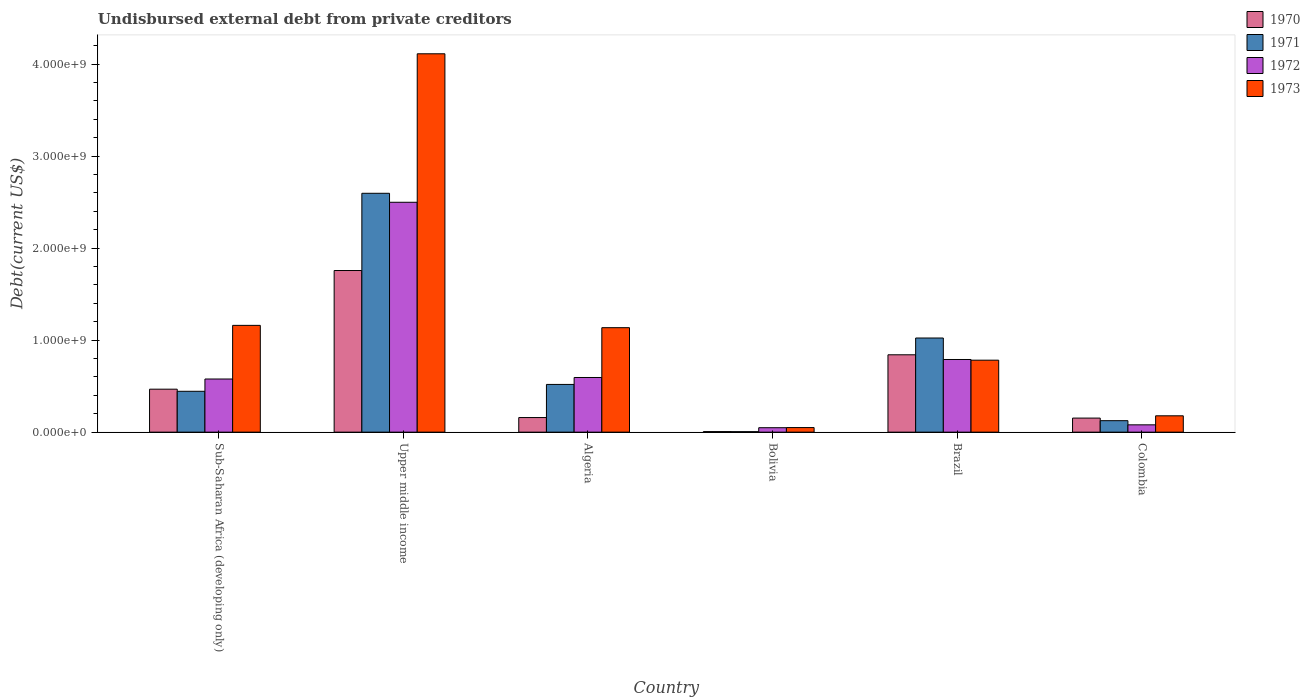How many groups of bars are there?
Offer a very short reply. 6. Are the number of bars per tick equal to the number of legend labels?
Keep it short and to the point. Yes. How many bars are there on the 1st tick from the left?
Give a very brief answer. 4. What is the label of the 3rd group of bars from the left?
Your response must be concise. Algeria. What is the total debt in 1972 in Algeria?
Your answer should be very brief. 5.94e+08. Across all countries, what is the maximum total debt in 1970?
Give a very brief answer. 1.76e+09. Across all countries, what is the minimum total debt in 1972?
Provide a short and direct response. 4.82e+07. In which country was the total debt in 1971 maximum?
Your answer should be compact. Upper middle income. What is the total total debt in 1970 in the graph?
Provide a succinct answer. 3.38e+09. What is the difference between the total debt in 1972 in Algeria and that in Brazil?
Your answer should be very brief. -1.95e+08. What is the difference between the total debt in 1970 in Colombia and the total debt in 1971 in Bolivia?
Offer a terse response. 1.48e+08. What is the average total debt in 1973 per country?
Provide a short and direct response. 1.24e+09. What is the difference between the total debt of/in 1973 and total debt of/in 1970 in Algeria?
Your response must be concise. 9.77e+08. What is the ratio of the total debt in 1972 in Bolivia to that in Upper middle income?
Offer a very short reply. 0.02. Is the total debt in 1970 in Sub-Saharan Africa (developing only) less than that in Upper middle income?
Your answer should be very brief. Yes. What is the difference between the highest and the second highest total debt in 1973?
Your answer should be very brief. 2.95e+09. What is the difference between the highest and the lowest total debt in 1970?
Offer a terse response. 1.75e+09. Is the sum of the total debt in 1973 in Bolivia and Upper middle income greater than the maximum total debt in 1970 across all countries?
Make the answer very short. Yes. Is it the case that in every country, the sum of the total debt in 1970 and total debt in 1972 is greater than the sum of total debt in 1973 and total debt in 1971?
Provide a succinct answer. No. What does the 3rd bar from the left in Bolivia represents?
Your answer should be very brief. 1972. How many bars are there?
Offer a very short reply. 24. How many countries are there in the graph?
Make the answer very short. 6. What is the difference between two consecutive major ticks on the Y-axis?
Provide a succinct answer. 1.00e+09. Does the graph contain grids?
Your answer should be very brief. No. Where does the legend appear in the graph?
Provide a short and direct response. Top right. What is the title of the graph?
Keep it short and to the point. Undisbursed external debt from private creditors. What is the label or title of the Y-axis?
Provide a succinct answer. Debt(current US$). What is the Debt(current US$) of 1970 in Sub-Saharan Africa (developing only)?
Your answer should be compact. 4.67e+08. What is the Debt(current US$) of 1971 in Sub-Saharan Africa (developing only)?
Give a very brief answer. 4.44e+08. What is the Debt(current US$) in 1972 in Sub-Saharan Africa (developing only)?
Provide a short and direct response. 5.77e+08. What is the Debt(current US$) in 1973 in Sub-Saharan Africa (developing only)?
Your answer should be compact. 1.16e+09. What is the Debt(current US$) of 1970 in Upper middle income?
Keep it short and to the point. 1.76e+09. What is the Debt(current US$) in 1971 in Upper middle income?
Give a very brief answer. 2.60e+09. What is the Debt(current US$) in 1972 in Upper middle income?
Ensure brevity in your answer.  2.50e+09. What is the Debt(current US$) of 1973 in Upper middle income?
Your answer should be very brief. 4.11e+09. What is the Debt(current US$) in 1970 in Algeria?
Keep it short and to the point. 1.59e+08. What is the Debt(current US$) of 1971 in Algeria?
Your answer should be very brief. 5.18e+08. What is the Debt(current US$) of 1972 in Algeria?
Make the answer very short. 5.94e+08. What is the Debt(current US$) of 1973 in Algeria?
Keep it short and to the point. 1.14e+09. What is the Debt(current US$) of 1970 in Bolivia?
Give a very brief answer. 6.05e+06. What is the Debt(current US$) in 1971 in Bolivia?
Keep it short and to the point. 5.25e+06. What is the Debt(current US$) of 1972 in Bolivia?
Provide a succinct answer. 4.82e+07. What is the Debt(current US$) in 1973 in Bolivia?
Your answer should be compact. 4.98e+07. What is the Debt(current US$) of 1970 in Brazil?
Provide a succinct answer. 8.41e+08. What is the Debt(current US$) in 1971 in Brazil?
Your response must be concise. 1.02e+09. What is the Debt(current US$) of 1972 in Brazil?
Ensure brevity in your answer.  7.89e+08. What is the Debt(current US$) in 1973 in Brazil?
Make the answer very short. 7.82e+08. What is the Debt(current US$) in 1970 in Colombia?
Your answer should be very brief. 1.53e+08. What is the Debt(current US$) in 1971 in Colombia?
Offer a very short reply. 1.25e+08. What is the Debt(current US$) of 1972 in Colombia?
Give a very brief answer. 7.95e+07. What is the Debt(current US$) of 1973 in Colombia?
Your response must be concise. 1.78e+08. Across all countries, what is the maximum Debt(current US$) of 1970?
Offer a very short reply. 1.76e+09. Across all countries, what is the maximum Debt(current US$) of 1971?
Make the answer very short. 2.60e+09. Across all countries, what is the maximum Debt(current US$) of 1972?
Your answer should be very brief. 2.50e+09. Across all countries, what is the maximum Debt(current US$) in 1973?
Offer a very short reply. 4.11e+09. Across all countries, what is the minimum Debt(current US$) in 1970?
Give a very brief answer. 6.05e+06. Across all countries, what is the minimum Debt(current US$) of 1971?
Your answer should be very brief. 5.25e+06. Across all countries, what is the minimum Debt(current US$) of 1972?
Your response must be concise. 4.82e+07. Across all countries, what is the minimum Debt(current US$) in 1973?
Ensure brevity in your answer.  4.98e+07. What is the total Debt(current US$) of 1970 in the graph?
Give a very brief answer. 3.38e+09. What is the total Debt(current US$) in 1971 in the graph?
Your answer should be very brief. 4.71e+09. What is the total Debt(current US$) in 1972 in the graph?
Provide a succinct answer. 4.59e+09. What is the total Debt(current US$) of 1973 in the graph?
Your answer should be compact. 7.42e+09. What is the difference between the Debt(current US$) in 1970 in Sub-Saharan Africa (developing only) and that in Upper middle income?
Ensure brevity in your answer.  -1.29e+09. What is the difference between the Debt(current US$) in 1971 in Sub-Saharan Africa (developing only) and that in Upper middle income?
Provide a short and direct response. -2.15e+09. What is the difference between the Debt(current US$) in 1972 in Sub-Saharan Africa (developing only) and that in Upper middle income?
Provide a succinct answer. -1.92e+09. What is the difference between the Debt(current US$) in 1973 in Sub-Saharan Africa (developing only) and that in Upper middle income?
Offer a terse response. -2.95e+09. What is the difference between the Debt(current US$) of 1970 in Sub-Saharan Africa (developing only) and that in Algeria?
Offer a terse response. 3.08e+08. What is the difference between the Debt(current US$) in 1971 in Sub-Saharan Africa (developing only) and that in Algeria?
Give a very brief answer. -7.44e+07. What is the difference between the Debt(current US$) in 1972 in Sub-Saharan Africa (developing only) and that in Algeria?
Ensure brevity in your answer.  -1.64e+07. What is the difference between the Debt(current US$) in 1973 in Sub-Saharan Africa (developing only) and that in Algeria?
Offer a terse response. 2.52e+07. What is the difference between the Debt(current US$) of 1970 in Sub-Saharan Africa (developing only) and that in Bolivia?
Your response must be concise. 4.61e+08. What is the difference between the Debt(current US$) in 1971 in Sub-Saharan Africa (developing only) and that in Bolivia?
Provide a short and direct response. 4.39e+08. What is the difference between the Debt(current US$) in 1972 in Sub-Saharan Africa (developing only) and that in Bolivia?
Keep it short and to the point. 5.29e+08. What is the difference between the Debt(current US$) of 1973 in Sub-Saharan Africa (developing only) and that in Bolivia?
Give a very brief answer. 1.11e+09. What is the difference between the Debt(current US$) of 1970 in Sub-Saharan Africa (developing only) and that in Brazil?
Give a very brief answer. -3.74e+08. What is the difference between the Debt(current US$) in 1971 in Sub-Saharan Africa (developing only) and that in Brazil?
Make the answer very short. -5.79e+08. What is the difference between the Debt(current US$) of 1972 in Sub-Saharan Africa (developing only) and that in Brazil?
Your response must be concise. -2.12e+08. What is the difference between the Debt(current US$) of 1973 in Sub-Saharan Africa (developing only) and that in Brazil?
Give a very brief answer. 3.78e+08. What is the difference between the Debt(current US$) in 1970 in Sub-Saharan Africa (developing only) and that in Colombia?
Make the answer very short. 3.14e+08. What is the difference between the Debt(current US$) of 1971 in Sub-Saharan Africa (developing only) and that in Colombia?
Provide a succinct answer. 3.19e+08. What is the difference between the Debt(current US$) of 1972 in Sub-Saharan Africa (developing only) and that in Colombia?
Provide a succinct answer. 4.98e+08. What is the difference between the Debt(current US$) of 1973 in Sub-Saharan Africa (developing only) and that in Colombia?
Offer a terse response. 9.83e+08. What is the difference between the Debt(current US$) of 1970 in Upper middle income and that in Algeria?
Ensure brevity in your answer.  1.60e+09. What is the difference between the Debt(current US$) in 1971 in Upper middle income and that in Algeria?
Your answer should be compact. 2.08e+09. What is the difference between the Debt(current US$) in 1972 in Upper middle income and that in Algeria?
Offer a very short reply. 1.90e+09. What is the difference between the Debt(current US$) of 1973 in Upper middle income and that in Algeria?
Provide a succinct answer. 2.98e+09. What is the difference between the Debt(current US$) in 1970 in Upper middle income and that in Bolivia?
Keep it short and to the point. 1.75e+09. What is the difference between the Debt(current US$) in 1971 in Upper middle income and that in Bolivia?
Provide a succinct answer. 2.59e+09. What is the difference between the Debt(current US$) in 1972 in Upper middle income and that in Bolivia?
Your answer should be compact. 2.45e+09. What is the difference between the Debt(current US$) of 1973 in Upper middle income and that in Bolivia?
Give a very brief answer. 4.06e+09. What is the difference between the Debt(current US$) in 1970 in Upper middle income and that in Brazil?
Make the answer very short. 9.16e+08. What is the difference between the Debt(current US$) of 1971 in Upper middle income and that in Brazil?
Your answer should be compact. 1.57e+09. What is the difference between the Debt(current US$) of 1972 in Upper middle income and that in Brazil?
Give a very brief answer. 1.71e+09. What is the difference between the Debt(current US$) in 1973 in Upper middle income and that in Brazil?
Provide a succinct answer. 3.33e+09. What is the difference between the Debt(current US$) of 1970 in Upper middle income and that in Colombia?
Your response must be concise. 1.60e+09. What is the difference between the Debt(current US$) of 1971 in Upper middle income and that in Colombia?
Your answer should be very brief. 2.47e+09. What is the difference between the Debt(current US$) of 1972 in Upper middle income and that in Colombia?
Ensure brevity in your answer.  2.42e+09. What is the difference between the Debt(current US$) of 1973 in Upper middle income and that in Colombia?
Keep it short and to the point. 3.93e+09. What is the difference between the Debt(current US$) of 1970 in Algeria and that in Bolivia?
Give a very brief answer. 1.53e+08. What is the difference between the Debt(current US$) of 1971 in Algeria and that in Bolivia?
Keep it short and to the point. 5.13e+08. What is the difference between the Debt(current US$) of 1972 in Algeria and that in Bolivia?
Provide a short and direct response. 5.46e+08. What is the difference between the Debt(current US$) in 1973 in Algeria and that in Bolivia?
Your response must be concise. 1.09e+09. What is the difference between the Debt(current US$) in 1970 in Algeria and that in Brazil?
Offer a very short reply. -6.82e+08. What is the difference between the Debt(current US$) in 1971 in Algeria and that in Brazil?
Keep it short and to the point. -5.05e+08. What is the difference between the Debt(current US$) of 1972 in Algeria and that in Brazil?
Keep it short and to the point. -1.95e+08. What is the difference between the Debt(current US$) in 1973 in Algeria and that in Brazil?
Offer a very short reply. 3.53e+08. What is the difference between the Debt(current US$) of 1970 in Algeria and that in Colombia?
Keep it short and to the point. 5.77e+06. What is the difference between the Debt(current US$) of 1971 in Algeria and that in Colombia?
Your answer should be very brief. 3.94e+08. What is the difference between the Debt(current US$) in 1972 in Algeria and that in Colombia?
Offer a terse response. 5.14e+08. What is the difference between the Debt(current US$) of 1973 in Algeria and that in Colombia?
Offer a terse response. 9.58e+08. What is the difference between the Debt(current US$) of 1970 in Bolivia and that in Brazil?
Offer a very short reply. -8.35e+08. What is the difference between the Debt(current US$) of 1971 in Bolivia and that in Brazil?
Provide a short and direct response. -1.02e+09. What is the difference between the Debt(current US$) in 1972 in Bolivia and that in Brazil?
Offer a very short reply. -7.41e+08. What is the difference between the Debt(current US$) of 1973 in Bolivia and that in Brazil?
Offer a very short reply. -7.32e+08. What is the difference between the Debt(current US$) in 1970 in Bolivia and that in Colombia?
Your response must be concise. -1.47e+08. What is the difference between the Debt(current US$) of 1971 in Bolivia and that in Colombia?
Your response must be concise. -1.19e+08. What is the difference between the Debt(current US$) of 1972 in Bolivia and that in Colombia?
Keep it short and to the point. -3.13e+07. What is the difference between the Debt(current US$) in 1973 in Bolivia and that in Colombia?
Offer a terse response. -1.28e+08. What is the difference between the Debt(current US$) in 1970 in Brazil and that in Colombia?
Make the answer very short. 6.88e+08. What is the difference between the Debt(current US$) in 1971 in Brazil and that in Colombia?
Make the answer very short. 8.98e+08. What is the difference between the Debt(current US$) of 1972 in Brazil and that in Colombia?
Give a very brief answer. 7.10e+08. What is the difference between the Debt(current US$) in 1973 in Brazil and that in Colombia?
Keep it short and to the point. 6.04e+08. What is the difference between the Debt(current US$) of 1970 in Sub-Saharan Africa (developing only) and the Debt(current US$) of 1971 in Upper middle income?
Offer a very short reply. -2.13e+09. What is the difference between the Debt(current US$) in 1970 in Sub-Saharan Africa (developing only) and the Debt(current US$) in 1972 in Upper middle income?
Offer a terse response. -2.03e+09. What is the difference between the Debt(current US$) of 1970 in Sub-Saharan Africa (developing only) and the Debt(current US$) of 1973 in Upper middle income?
Your answer should be compact. -3.64e+09. What is the difference between the Debt(current US$) in 1971 in Sub-Saharan Africa (developing only) and the Debt(current US$) in 1972 in Upper middle income?
Make the answer very short. -2.05e+09. What is the difference between the Debt(current US$) in 1971 in Sub-Saharan Africa (developing only) and the Debt(current US$) in 1973 in Upper middle income?
Ensure brevity in your answer.  -3.67e+09. What is the difference between the Debt(current US$) in 1972 in Sub-Saharan Africa (developing only) and the Debt(current US$) in 1973 in Upper middle income?
Provide a short and direct response. -3.53e+09. What is the difference between the Debt(current US$) in 1970 in Sub-Saharan Africa (developing only) and the Debt(current US$) in 1971 in Algeria?
Provide a succinct answer. -5.16e+07. What is the difference between the Debt(current US$) in 1970 in Sub-Saharan Africa (developing only) and the Debt(current US$) in 1972 in Algeria?
Keep it short and to the point. -1.27e+08. What is the difference between the Debt(current US$) in 1970 in Sub-Saharan Africa (developing only) and the Debt(current US$) in 1973 in Algeria?
Your answer should be compact. -6.68e+08. What is the difference between the Debt(current US$) in 1971 in Sub-Saharan Africa (developing only) and the Debt(current US$) in 1972 in Algeria?
Provide a succinct answer. -1.50e+08. What is the difference between the Debt(current US$) in 1971 in Sub-Saharan Africa (developing only) and the Debt(current US$) in 1973 in Algeria?
Your answer should be very brief. -6.91e+08. What is the difference between the Debt(current US$) in 1972 in Sub-Saharan Africa (developing only) and the Debt(current US$) in 1973 in Algeria?
Provide a short and direct response. -5.58e+08. What is the difference between the Debt(current US$) in 1970 in Sub-Saharan Africa (developing only) and the Debt(current US$) in 1971 in Bolivia?
Provide a short and direct response. 4.62e+08. What is the difference between the Debt(current US$) in 1970 in Sub-Saharan Africa (developing only) and the Debt(current US$) in 1972 in Bolivia?
Provide a short and direct response. 4.19e+08. What is the difference between the Debt(current US$) of 1970 in Sub-Saharan Africa (developing only) and the Debt(current US$) of 1973 in Bolivia?
Offer a very short reply. 4.17e+08. What is the difference between the Debt(current US$) of 1971 in Sub-Saharan Africa (developing only) and the Debt(current US$) of 1972 in Bolivia?
Give a very brief answer. 3.96e+08. What is the difference between the Debt(current US$) of 1971 in Sub-Saharan Africa (developing only) and the Debt(current US$) of 1973 in Bolivia?
Ensure brevity in your answer.  3.94e+08. What is the difference between the Debt(current US$) in 1972 in Sub-Saharan Africa (developing only) and the Debt(current US$) in 1973 in Bolivia?
Provide a short and direct response. 5.28e+08. What is the difference between the Debt(current US$) of 1970 in Sub-Saharan Africa (developing only) and the Debt(current US$) of 1971 in Brazil?
Provide a succinct answer. -5.56e+08. What is the difference between the Debt(current US$) in 1970 in Sub-Saharan Africa (developing only) and the Debt(current US$) in 1972 in Brazil?
Provide a short and direct response. -3.23e+08. What is the difference between the Debt(current US$) in 1970 in Sub-Saharan Africa (developing only) and the Debt(current US$) in 1973 in Brazil?
Provide a short and direct response. -3.15e+08. What is the difference between the Debt(current US$) of 1971 in Sub-Saharan Africa (developing only) and the Debt(current US$) of 1972 in Brazil?
Ensure brevity in your answer.  -3.45e+08. What is the difference between the Debt(current US$) of 1971 in Sub-Saharan Africa (developing only) and the Debt(current US$) of 1973 in Brazil?
Ensure brevity in your answer.  -3.38e+08. What is the difference between the Debt(current US$) of 1972 in Sub-Saharan Africa (developing only) and the Debt(current US$) of 1973 in Brazil?
Give a very brief answer. -2.05e+08. What is the difference between the Debt(current US$) of 1970 in Sub-Saharan Africa (developing only) and the Debt(current US$) of 1971 in Colombia?
Your answer should be compact. 3.42e+08. What is the difference between the Debt(current US$) in 1970 in Sub-Saharan Africa (developing only) and the Debt(current US$) in 1972 in Colombia?
Make the answer very short. 3.87e+08. What is the difference between the Debt(current US$) of 1970 in Sub-Saharan Africa (developing only) and the Debt(current US$) of 1973 in Colombia?
Your answer should be compact. 2.89e+08. What is the difference between the Debt(current US$) of 1971 in Sub-Saharan Africa (developing only) and the Debt(current US$) of 1972 in Colombia?
Make the answer very short. 3.65e+08. What is the difference between the Debt(current US$) in 1971 in Sub-Saharan Africa (developing only) and the Debt(current US$) in 1973 in Colombia?
Provide a succinct answer. 2.66e+08. What is the difference between the Debt(current US$) of 1972 in Sub-Saharan Africa (developing only) and the Debt(current US$) of 1973 in Colombia?
Your answer should be compact. 4.00e+08. What is the difference between the Debt(current US$) in 1970 in Upper middle income and the Debt(current US$) in 1971 in Algeria?
Provide a short and direct response. 1.24e+09. What is the difference between the Debt(current US$) of 1970 in Upper middle income and the Debt(current US$) of 1972 in Algeria?
Offer a terse response. 1.16e+09. What is the difference between the Debt(current US$) in 1970 in Upper middle income and the Debt(current US$) in 1973 in Algeria?
Provide a short and direct response. 6.21e+08. What is the difference between the Debt(current US$) of 1971 in Upper middle income and the Debt(current US$) of 1972 in Algeria?
Provide a succinct answer. 2.00e+09. What is the difference between the Debt(current US$) in 1971 in Upper middle income and the Debt(current US$) in 1973 in Algeria?
Provide a short and direct response. 1.46e+09. What is the difference between the Debt(current US$) of 1972 in Upper middle income and the Debt(current US$) of 1973 in Algeria?
Keep it short and to the point. 1.36e+09. What is the difference between the Debt(current US$) in 1970 in Upper middle income and the Debt(current US$) in 1971 in Bolivia?
Provide a short and direct response. 1.75e+09. What is the difference between the Debt(current US$) in 1970 in Upper middle income and the Debt(current US$) in 1972 in Bolivia?
Provide a succinct answer. 1.71e+09. What is the difference between the Debt(current US$) of 1970 in Upper middle income and the Debt(current US$) of 1973 in Bolivia?
Offer a terse response. 1.71e+09. What is the difference between the Debt(current US$) of 1971 in Upper middle income and the Debt(current US$) of 1972 in Bolivia?
Your answer should be very brief. 2.55e+09. What is the difference between the Debt(current US$) of 1971 in Upper middle income and the Debt(current US$) of 1973 in Bolivia?
Your response must be concise. 2.55e+09. What is the difference between the Debt(current US$) of 1972 in Upper middle income and the Debt(current US$) of 1973 in Bolivia?
Offer a very short reply. 2.45e+09. What is the difference between the Debt(current US$) in 1970 in Upper middle income and the Debt(current US$) in 1971 in Brazil?
Offer a very short reply. 7.33e+08. What is the difference between the Debt(current US$) in 1970 in Upper middle income and the Debt(current US$) in 1972 in Brazil?
Your answer should be very brief. 9.67e+08. What is the difference between the Debt(current US$) in 1970 in Upper middle income and the Debt(current US$) in 1973 in Brazil?
Your answer should be very brief. 9.74e+08. What is the difference between the Debt(current US$) of 1971 in Upper middle income and the Debt(current US$) of 1972 in Brazil?
Offer a terse response. 1.81e+09. What is the difference between the Debt(current US$) in 1971 in Upper middle income and the Debt(current US$) in 1973 in Brazil?
Keep it short and to the point. 1.81e+09. What is the difference between the Debt(current US$) of 1972 in Upper middle income and the Debt(current US$) of 1973 in Brazil?
Ensure brevity in your answer.  1.72e+09. What is the difference between the Debt(current US$) in 1970 in Upper middle income and the Debt(current US$) in 1971 in Colombia?
Provide a short and direct response. 1.63e+09. What is the difference between the Debt(current US$) of 1970 in Upper middle income and the Debt(current US$) of 1972 in Colombia?
Provide a succinct answer. 1.68e+09. What is the difference between the Debt(current US$) in 1970 in Upper middle income and the Debt(current US$) in 1973 in Colombia?
Your answer should be very brief. 1.58e+09. What is the difference between the Debt(current US$) of 1971 in Upper middle income and the Debt(current US$) of 1972 in Colombia?
Offer a terse response. 2.52e+09. What is the difference between the Debt(current US$) of 1971 in Upper middle income and the Debt(current US$) of 1973 in Colombia?
Offer a very short reply. 2.42e+09. What is the difference between the Debt(current US$) in 1972 in Upper middle income and the Debt(current US$) in 1973 in Colombia?
Give a very brief answer. 2.32e+09. What is the difference between the Debt(current US$) of 1970 in Algeria and the Debt(current US$) of 1971 in Bolivia?
Ensure brevity in your answer.  1.53e+08. What is the difference between the Debt(current US$) in 1970 in Algeria and the Debt(current US$) in 1972 in Bolivia?
Make the answer very short. 1.10e+08. What is the difference between the Debt(current US$) of 1970 in Algeria and the Debt(current US$) of 1973 in Bolivia?
Ensure brevity in your answer.  1.09e+08. What is the difference between the Debt(current US$) of 1971 in Algeria and the Debt(current US$) of 1972 in Bolivia?
Give a very brief answer. 4.70e+08. What is the difference between the Debt(current US$) in 1971 in Algeria and the Debt(current US$) in 1973 in Bolivia?
Your answer should be compact. 4.69e+08. What is the difference between the Debt(current US$) of 1972 in Algeria and the Debt(current US$) of 1973 in Bolivia?
Give a very brief answer. 5.44e+08. What is the difference between the Debt(current US$) in 1970 in Algeria and the Debt(current US$) in 1971 in Brazil?
Keep it short and to the point. -8.64e+08. What is the difference between the Debt(current US$) in 1970 in Algeria and the Debt(current US$) in 1972 in Brazil?
Provide a succinct answer. -6.31e+08. What is the difference between the Debt(current US$) of 1970 in Algeria and the Debt(current US$) of 1973 in Brazil?
Make the answer very short. -6.23e+08. What is the difference between the Debt(current US$) of 1971 in Algeria and the Debt(current US$) of 1972 in Brazil?
Ensure brevity in your answer.  -2.71e+08. What is the difference between the Debt(current US$) in 1971 in Algeria and the Debt(current US$) in 1973 in Brazil?
Keep it short and to the point. -2.64e+08. What is the difference between the Debt(current US$) in 1972 in Algeria and the Debt(current US$) in 1973 in Brazil?
Keep it short and to the point. -1.88e+08. What is the difference between the Debt(current US$) of 1970 in Algeria and the Debt(current US$) of 1971 in Colombia?
Provide a succinct answer. 3.40e+07. What is the difference between the Debt(current US$) of 1970 in Algeria and the Debt(current US$) of 1972 in Colombia?
Your answer should be very brief. 7.91e+07. What is the difference between the Debt(current US$) in 1970 in Algeria and the Debt(current US$) in 1973 in Colombia?
Offer a very short reply. -1.90e+07. What is the difference between the Debt(current US$) in 1971 in Algeria and the Debt(current US$) in 1972 in Colombia?
Offer a very short reply. 4.39e+08. What is the difference between the Debt(current US$) in 1971 in Algeria and the Debt(current US$) in 1973 in Colombia?
Provide a succinct answer. 3.41e+08. What is the difference between the Debt(current US$) in 1972 in Algeria and the Debt(current US$) in 1973 in Colombia?
Offer a terse response. 4.16e+08. What is the difference between the Debt(current US$) of 1970 in Bolivia and the Debt(current US$) of 1971 in Brazil?
Your answer should be very brief. -1.02e+09. What is the difference between the Debt(current US$) in 1970 in Bolivia and the Debt(current US$) in 1972 in Brazil?
Your answer should be very brief. -7.83e+08. What is the difference between the Debt(current US$) in 1970 in Bolivia and the Debt(current US$) in 1973 in Brazil?
Offer a very short reply. -7.76e+08. What is the difference between the Debt(current US$) of 1971 in Bolivia and the Debt(current US$) of 1972 in Brazil?
Provide a succinct answer. -7.84e+08. What is the difference between the Debt(current US$) in 1971 in Bolivia and the Debt(current US$) in 1973 in Brazil?
Provide a short and direct response. -7.77e+08. What is the difference between the Debt(current US$) of 1972 in Bolivia and the Debt(current US$) of 1973 in Brazil?
Keep it short and to the point. -7.34e+08. What is the difference between the Debt(current US$) in 1970 in Bolivia and the Debt(current US$) in 1971 in Colombia?
Make the answer very short. -1.19e+08. What is the difference between the Debt(current US$) of 1970 in Bolivia and the Debt(current US$) of 1972 in Colombia?
Make the answer very short. -7.34e+07. What is the difference between the Debt(current US$) of 1970 in Bolivia and the Debt(current US$) of 1973 in Colombia?
Your answer should be compact. -1.72e+08. What is the difference between the Debt(current US$) in 1971 in Bolivia and the Debt(current US$) in 1972 in Colombia?
Your answer should be compact. -7.42e+07. What is the difference between the Debt(current US$) of 1971 in Bolivia and the Debt(current US$) of 1973 in Colombia?
Ensure brevity in your answer.  -1.72e+08. What is the difference between the Debt(current US$) in 1972 in Bolivia and the Debt(current US$) in 1973 in Colombia?
Give a very brief answer. -1.29e+08. What is the difference between the Debt(current US$) in 1970 in Brazil and the Debt(current US$) in 1971 in Colombia?
Keep it short and to the point. 7.16e+08. What is the difference between the Debt(current US$) of 1970 in Brazil and the Debt(current US$) of 1972 in Colombia?
Your answer should be compact. 7.61e+08. What is the difference between the Debt(current US$) in 1970 in Brazil and the Debt(current US$) in 1973 in Colombia?
Ensure brevity in your answer.  6.63e+08. What is the difference between the Debt(current US$) in 1971 in Brazil and the Debt(current US$) in 1972 in Colombia?
Ensure brevity in your answer.  9.44e+08. What is the difference between the Debt(current US$) in 1971 in Brazil and the Debt(current US$) in 1973 in Colombia?
Keep it short and to the point. 8.45e+08. What is the difference between the Debt(current US$) of 1972 in Brazil and the Debt(current US$) of 1973 in Colombia?
Provide a succinct answer. 6.12e+08. What is the average Debt(current US$) in 1970 per country?
Give a very brief answer. 5.64e+08. What is the average Debt(current US$) in 1971 per country?
Provide a succinct answer. 7.85e+08. What is the average Debt(current US$) of 1972 per country?
Your response must be concise. 7.64e+08. What is the average Debt(current US$) in 1973 per country?
Offer a very short reply. 1.24e+09. What is the difference between the Debt(current US$) in 1970 and Debt(current US$) in 1971 in Sub-Saharan Africa (developing only)?
Provide a succinct answer. 2.28e+07. What is the difference between the Debt(current US$) in 1970 and Debt(current US$) in 1972 in Sub-Saharan Africa (developing only)?
Offer a very short reply. -1.11e+08. What is the difference between the Debt(current US$) in 1970 and Debt(current US$) in 1973 in Sub-Saharan Africa (developing only)?
Offer a very short reply. -6.94e+08. What is the difference between the Debt(current US$) in 1971 and Debt(current US$) in 1972 in Sub-Saharan Africa (developing only)?
Give a very brief answer. -1.33e+08. What is the difference between the Debt(current US$) in 1971 and Debt(current US$) in 1973 in Sub-Saharan Africa (developing only)?
Provide a succinct answer. -7.16e+08. What is the difference between the Debt(current US$) of 1972 and Debt(current US$) of 1973 in Sub-Saharan Africa (developing only)?
Give a very brief answer. -5.83e+08. What is the difference between the Debt(current US$) in 1970 and Debt(current US$) in 1971 in Upper middle income?
Make the answer very short. -8.39e+08. What is the difference between the Debt(current US$) of 1970 and Debt(current US$) of 1972 in Upper middle income?
Your answer should be compact. -7.42e+08. What is the difference between the Debt(current US$) in 1970 and Debt(current US$) in 1973 in Upper middle income?
Your answer should be compact. -2.36e+09. What is the difference between the Debt(current US$) of 1971 and Debt(current US$) of 1972 in Upper middle income?
Ensure brevity in your answer.  9.75e+07. What is the difference between the Debt(current US$) of 1971 and Debt(current US$) of 1973 in Upper middle income?
Keep it short and to the point. -1.52e+09. What is the difference between the Debt(current US$) of 1972 and Debt(current US$) of 1973 in Upper middle income?
Keep it short and to the point. -1.61e+09. What is the difference between the Debt(current US$) of 1970 and Debt(current US$) of 1971 in Algeria?
Offer a very short reply. -3.60e+08. What is the difference between the Debt(current US$) in 1970 and Debt(current US$) in 1972 in Algeria?
Make the answer very short. -4.35e+08. What is the difference between the Debt(current US$) of 1970 and Debt(current US$) of 1973 in Algeria?
Give a very brief answer. -9.77e+08. What is the difference between the Debt(current US$) in 1971 and Debt(current US$) in 1972 in Algeria?
Your response must be concise. -7.55e+07. What is the difference between the Debt(current US$) of 1971 and Debt(current US$) of 1973 in Algeria?
Your answer should be very brief. -6.17e+08. What is the difference between the Debt(current US$) in 1972 and Debt(current US$) in 1973 in Algeria?
Provide a short and direct response. -5.41e+08. What is the difference between the Debt(current US$) in 1970 and Debt(current US$) in 1971 in Bolivia?
Keep it short and to the point. 8.02e+05. What is the difference between the Debt(current US$) of 1970 and Debt(current US$) of 1972 in Bolivia?
Offer a very short reply. -4.22e+07. What is the difference between the Debt(current US$) in 1970 and Debt(current US$) in 1973 in Bolivia?
Make the answer very short. -4.37e+07. What is the difference between the Debt(current US$) of 1971 and Debt(current US$) of 1972 in Bolivia?
Provide a short and direct response. -4.30e+07. What is the difference between the Debt(current US$) of 1971 and Debt(current US$) of 1973 in Bolivia?
Your answer should be compact. -4.45e+07. What is the difference between the Debt(current US$) of 1972 and Debt(current US$) of 1973 in Bolivia?
Keep it short and to the point. -1.58e+06. What is the difference between the Debt(current US$) in 1970 and Debt(current US$) in 1971 in Brazil?
Offer a very short reply. -1.82e+08. What is the difference between the Debt(current US$) in 1970 and Debt(current US$) in 1972 in Brazil?
Keep it short and to the point. 5.12e+07. What is the difference between the Debt(current US$) in 1970 and Debt(current US$) in 1973 in Brazil?
Your answer should be compact. 5.86e+07. What is the difference between the Debt(current US$) of 1971 and Debt(current US$) of 1972 in Brazil?
Keep it short and to the point. 2.34e+08. What is the difference between the Debt(current US$) in 1971 and Debt(current US$) in 1973 in Brazil?
Your answer should be very brief. 2.41e+08. What is the difference between the Debt(current US$) of 1972 and Debt(current US$) of 1973 in Brazil?
Offer a very short reply. 7.41e+06. What is the difference between the Debt(current US$) of 1970 and Debt(current US$) of 1971 in Colombia?
Ensure brevity in your answer.  2.82e+07. What is the difference between the Debt(current US$) in 1970 and Debt(current US$) in 1972 in Colombia?
Provide a short and direct response. 7.33e+07. What is the difference between the Debt(current US$) in 1970 and Debt(current US$) in 1973 in Colombia?
Give a very brief answer. -2.48e+07. What is the difference between the Debt(current US$) in 1971 and Debt(current US$) in 1972 in Colombia?
Keep it short and to the point. 4.51e+07. What is the difference between the Debt(current US$) in 1971 and Debt(current US$) in 1973 in Colombia?
Make the answer very short. -5.30e+07. What is the difference between the Debt(current US$) in 1972 and Debt(current US$) in 1973 in Colombia?
Ensure brevity in your answer.  -9.81e+07. What is the ratio of the Debt(current US$) in 1970 in Sub-Saharan Africa (developing only) to that in Upper middle income?
Provide a short and direct response. 0.27. What is the ratio of the Debt(current US$) of 1971 in Sub-Saharan Africa (developing only) to that in Upper middle income?
Offer a very short reply. 0.17. What is the ratio of the Debt(current US$) of 1972 in Sub-Saharan Africa (developing only) to that in Upper middle income?
Ensure brevity in your answer.  0.23. What is the ratio of the Debt(current US$) of 1973 in Sub-Saharan Africa (developing only) to that in Upper middle income?
Offer a very short reply. 0.28. What is the ratio of the Debt(current US$) in 1970 in Sub-Saharan Africa (developing only) to that in Algeria?
Your answer should be compact. 2.94. What is the ratio of the Debt(current US$) in 1971 in Sub-Saharan Africa (developing only) to that in Algeria?
Ensure brevity in your answer.  0.86. What is the ratio of the Debt(current US$) in 1972 in Sub-Saharan Africa (developing only) to that in Algeria?
Offer a very short reply. 0.97. What is the ratio of the Debt(current US$) of 1973 in Sub-Saharan Africa (developing only) to that in Algeria?
Your answer should be very brief. 1.02. What is the ratio of the Debt(current US$) in 1970 in Sub-Saharan Africa (developing only) to that in Bolivia?
Make the answer very short. 77.19. What is the ratio of the Debt(current US$) in 1971 in Sub-Saharan Africa (developing only) to that in Bolivia?
Your answer should be compact. 84.64. What is the ratio of the Debt(current US$) in 1972 in Sub-Saharan Africa (developing only) to that in Bolivia?
Your response must be concise. 11.98. What is the ratio of the Debt(current US$) in 1973 in Sub-Saharan Africa (developing only) to that in Bolivia?
Offer a very short reply. 23.31. What is the ratio of the Debt(current US$) of 1970 in Sub-Saharan Africa (developing only) to that in Brazil?
Your answer should be compact. 0.56. What is the ratio of the Debt(current US$) in 1971 in Sub-Saharan Africa (developing only) to that in Brazil?
Give a very brief answer. 0.43. What is the ratio of the Debt(current US$) in 1972 in Sub-Saharan Africa (developing only) to that in Brazil?
Give a very brief answer. 0.73. What is the ratio of the Debt(current US$) in 1973 in Sub-Saharan Africa (developing only) to that in Brazil?
Offer a very short reply. 1.48. What is the ratio of the Debt(current US$) in 1970 in Sub-Saharan Africa (developing only) to that in Colombia?
Make the answer very short. 3.06. What is the ratio of the Debt(current US$) of 1971 in Sub-Saharan Africa (developing only) to that in Colombia?
Give a very brief answer. 3.56. What is the ratio of the Debt(current US$) of 1972 in Sub-Saharan Africa (developing only) to that in Colombia?
Provide a succinct answer. 7.27. What is the ratio of the Debt(current US$) of 1973 in Sub-Saharan Africa (developing only) to that in Colombia?
Provide a short and direct response. 6.53. What is the ratio of the Debt(current US$) in 1970 in Upper middle income to that in Algeria?
Your response must be concise. 11.08. What is the ratio of the Debt(current US$) in 1971 in Upper middle income to that in Algeria?
Provide a succinct answer. 5.01. What is the ratio of the Debt(current US$) in 1972 in Upper middle income to that in Algeria?
Give a very brief answer. 4.21. What is the ratio of the Debt(current US$) in 1973 in Upper middle income to that in Algeria?
Keep it short and to the point. 3.62. What is the ratio of the Debt(current US$) of 1970 in Upper middle income to that in Bolivia?
Provide a short and direct response. 290.38. What is the ratio of the Debt(current US$) of 1971 in Upper middle income to that in Bolivia?
Give a very brief answer. 494.74. What is the ratio of the Debt(current US$) in 1972 in Upper middle income to that in Bolivia?
Offer a very short reply. 51.81. What is the ratio of the Debt(current US$) in 1973 in Upper middle income to that in Bolivia?
Provide a short and direct response. 82.58. What is the ratio of the Debt(current US$) in 1970 in Upper middle income to that in Brazil?
Offer a very short reply. 2.09. What is the ratio of the Debt(current US$) in 1971 in Upper middle income to that in Brazil?
Give a very brief answer. 2.54. What is the ratio of the Debt(current US$) of 1972 in Upper middle income to that in Brazil?
Your answer should be compact. 3.16. What is the ratio of the Debt(current US$) of 1973 in Upper middle income to that in Brazil?
Keep it short and to the point. 5.26. What is the ratio of the Debt(current US$) of 1970 in Upper middle income to that in Colombia?
Keep it short and to the point. 11.49. What is the ratio of the Debt(current US$) in 1971 in Upper middle income to that in Colombia?
Make the answer very short. 20.83. What is the ratio of the Debt(current US$) of 1972 in Upper middle income to that in Colombia?
Keep it short and to the point. 31.43. What is the ratio of the Debt(current US$) in 1973 in Upper middle income to that in Colombia?
Provide a short and direct response. 23.15. What is the ratio of the Debt(current US$) of 1970 in Algeria to that in Bolivia?
Your answer should be very brief. 26.22. What is the ratio of the Debt(current US$) in 1971 in Algeria to that in Bolivia?
Make the answer very short. 98.83. What is the ratio of the Debt(current US$) of 1972 in Algeria to that in Bolivia?
Provide a succinct answer. 12.32. What is the ratio of the Debt(current US$) in 1973 in Algeria to that in Bolivia?
Your answer should be very brief. 22.8. What is the ratio of the Debt(current US$) in 1970 in Algeria to that in Brazil?
Offer a very short reply. 0.19. What is the ratio of the Debt(current US$) of 1971 in Algeria to that in Brazil?
Offer a terse response. 0.51. What is the ratio of the Debt(current US$) in 1972 in Algeria to that in Brazil?
Your response must be concise. 0.75. What is the ratio of the Debt(current US$) in 1973 in Algeria to that in Brazil?
Give a very brief answer. 1.45. What is the ratio of the Debt(current US$) in 1970 in Algeria to that in Colombia?
Provide a short and direct response. 1.04. What is the ratio of the Debt(current US$) in 1971 in Algeria to that in Colombia?
Your response must be concise. 4.16. What is the ratio of the Debt(current US$) in 1972 in Algeria to that in Colombia?
Ensure brevity in your answer.  7.47. What is the ratio of the Debt(current US$) of 1973 in Algeria to that in Colombia?
Offer a very short reply. 6.39. What is the ratio of the Debt(current US$) in 1970 in Bolivia to that in Brazil?
Offer a terse response. 0.01. What is the ratio of the Debt(current US$) of 1971 in Bolivia to that in Brazil?
Provide a short and direct response. 0.01. What is the ratio of the Debt(current US$) of 1972 in Bolivia to that in Brazil?
Provide a succinct answer. 0.06. What is the ratio of the Debt(current US$) in 1973 in Bolivia to that in Brazil?
Your response must be concise. 0.06. What is the ratio of the Debt(current US$) of 1970 in Bolivia to that in Colombia?
Ensure brevity in your answer.  0.04. What is the ratio of the Debt(current US$) in 1971 in Bolivia to that in Colombia?
Keep it short and to the point. 0.04. What is the ratio of the Debt(current US$) of 1972 in Bolivia to that in Colombia?
Make the answer very short. 0.61. What is the ratio of the Debt(current US$) in 1973 in Bolivia to that in Colombia?
Keep it short and to the point. 0.28. What is the ratio of the Debt(current US$) in 1970 in Brazil to that in Colombia?
Give a very brief answer. 5.5. What is the ratio of the Debt(current US$) in 1971 in Brazil to that in Colombia?
Your response must be concise. 8.21. What is the ratio of the Debt(current US$) of 1972 in Brazil to that in Colombia?
Keep it short and to the point. 9.93. What is the ratio of the Debt(current US$) of 1973 in Brazil to that in Colombia?
Your answer should be very brief. 4.4. What is the difference between the highest and the second highest Debt(current US$) in 1970?
Keep it short and to the point. 9.16e+08. What is the difference between the highest and the second highest Debt(current US$) in 1971?
Provide a short and direct response. 1.57e+09. What is the difference between the highest and the second highest Debt(current US$) of 1972?
Ensure brevity in your answer.  1.71e+09. What is the difference between the highest and the second highest Debt(current US$) of 1973?
Your answer should be very brief. 2.95e+09. What is the difference between the highest and the lowest Debt(current US$) in 1970?
Keep it short and to the point. 1.75e+09. What is the difference between the highest and the lowest Debt(current US$) in 1971?
Offer a very short reply. 2.59e+09. What is the difference between the highest and the lowest Debt(current US$) in 1972?
Provide a short and direct response. 2.45e+09. What is the difference between the highest and the lowest Debt(current US$) of 1973?
Offer a terse response. 4.06e+09. 